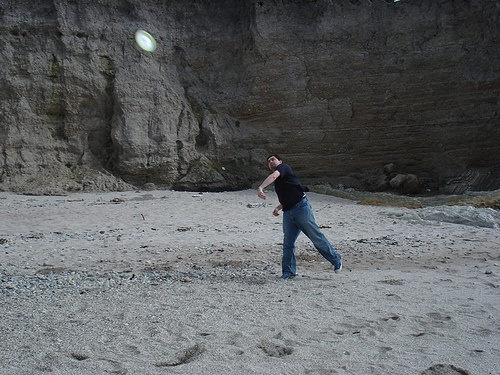Describe the objects in this image and their specific colors. I can see people in black, navy, blue, and darkgray tones and frisbee in black, lightgray, darkgray, beige, and gray tones in this image. 